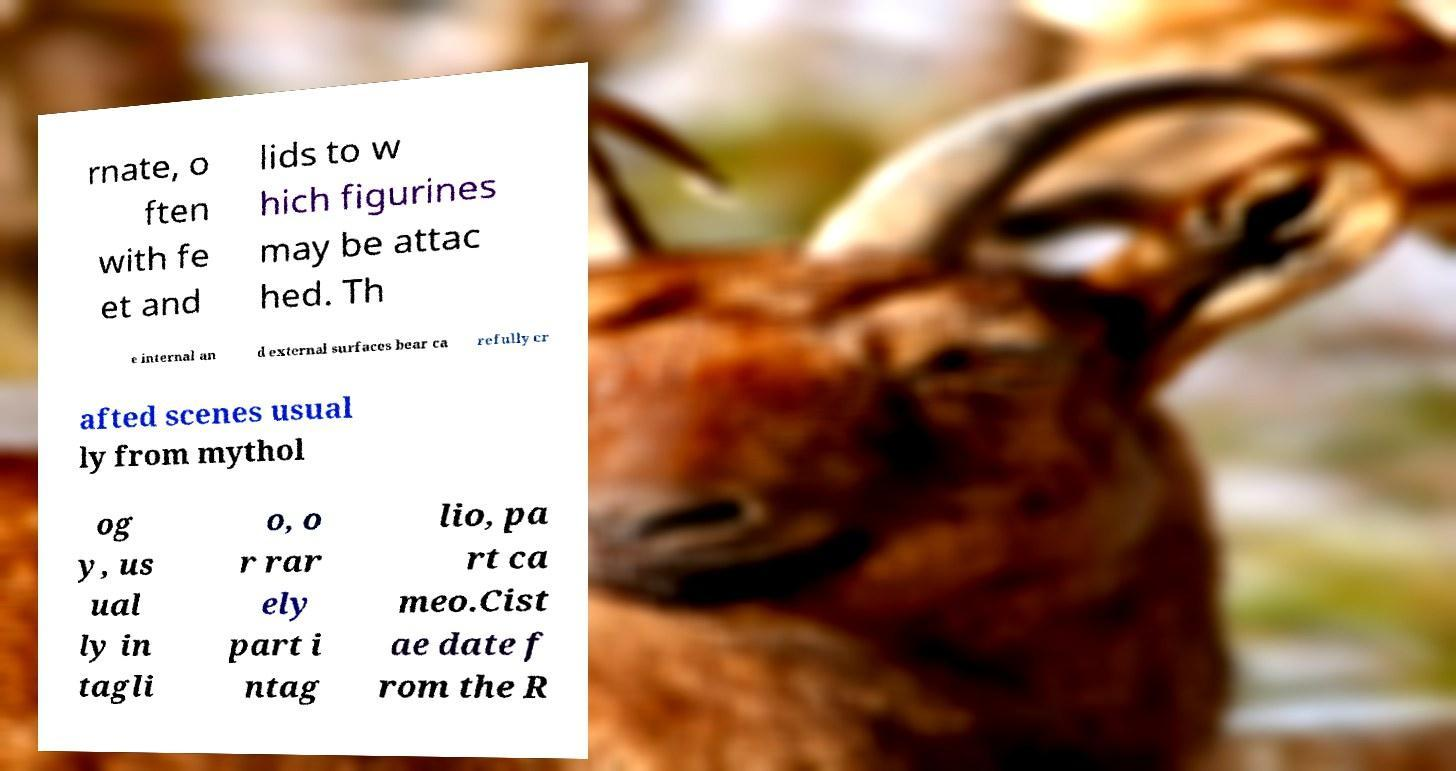Could you extract and type out the text from this image? rnate, o ften with fe et and lids to w hich figurines may be attac hed. Th e internal an d external surfaces bear ca refully cr afted scenes usual ly from mythol og y, us ual ly in tagli o, o r rar ely part i ntag lio, pa rt ca meo.Cist ae date f rom the R 